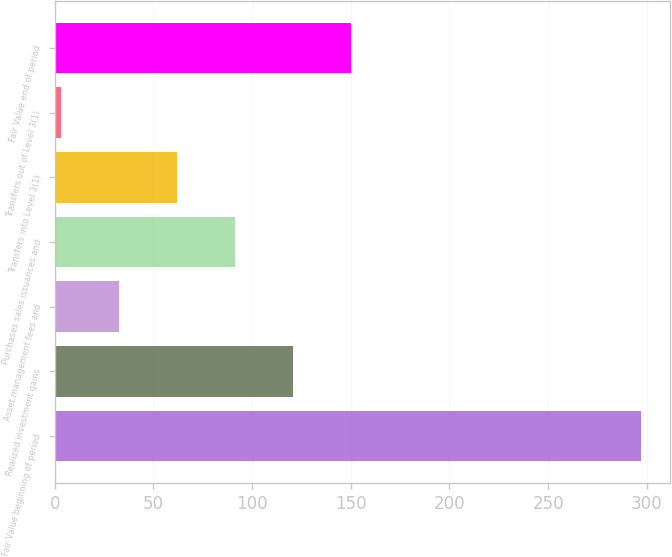<chart> <loc_0><loc_0><loc_500><loc_500><bar_chart><fcel>Fair Value beginning of period<fcel>Realized investment gains<fcel>Asset management fees and<fcel>Purchases sales issuances and<fcel>Transfers into Level 3(1)<fcel>Transfers out of Level 3(1)<fcel>Fair Value end of period<nl><fcel>297<fcel>120.6<fcel>32.4<fcel>91.2<fcel>61.8<fcel>3<fcel>150<nl></chart> 